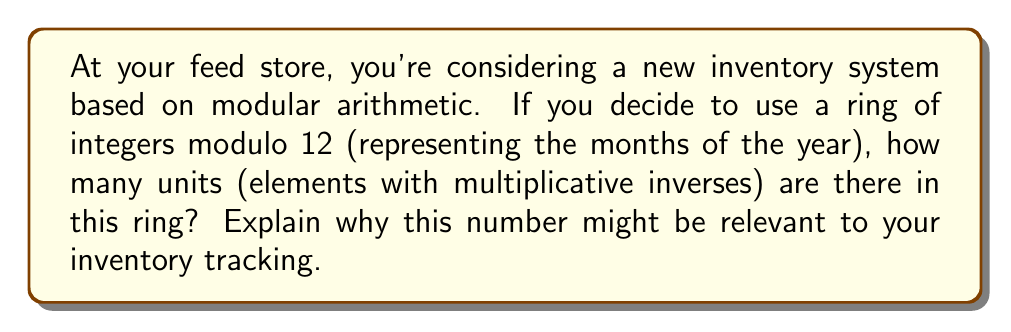Show me your answer to this math problem. To find the units in the ring of integers modulo 12, denoted as $\mathbb{Z}_{12}$, we need to identify the elements that have multiplicative inverses.

1) First, let's list all elements in $\mathbb{Z}_{12}$: 
   $\{0, 1, 2, 3, 4, 5, 6, 7, 8, 9, 10, 11\}$

2) An element $a$ is a unit if there exists a $b$ such that $ab \equiv 1 \pmod{12}$.

3) Let's check each element:

   - 1: $1 \cdot 1 \equiv 1 \pmod{12}$, so 1 is a unit.
   - 5: $5 \cdot 5 \equiv 1 \pmod{12}$, so 5 is a unit.
   - 7: $7 \cdot 7 \equiv 1 \pmod{12}$, so 7 is a unit.
   - 11: $11 \cdot 11 \equiv 1 \pmod{12}$, so 11 is a unit.

4) The elements 2, 3, 4, 6, 8, 9, 10 are not units because they share common factors with 12.
   0 is never a unit in any ring.

5) Therefore, there are 4 units in $\mathbb{Z}_{12}$: $\{1, 5, 7, 11\}$

This number is relevant to inventory tracking because:

a) It represents the number of months that have a unique "inverse" month in the year, which could be useful for cyclical inventory planning.
b) These units form a multiplicative group within the ring, which could be used to create a rotation system for certain types of feed or supplies.
c) Understanding the structure of $\mathbb{Z}_{12}$ can help in developing a robust monthly coding system for products or inventory cycles.
Answer: There are 4 units in the ring of integers modulo 12: $\{1, 5, 7, 11\}$. 